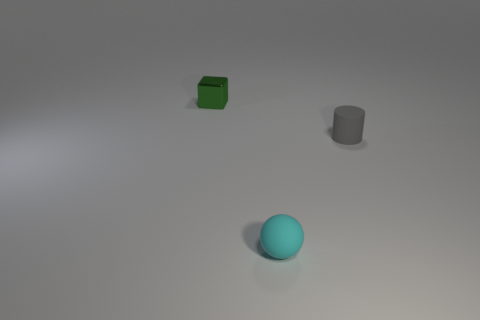Add 1 large blue rubber things. How many objects exist? 4 Subtract all cylinders. How many objects are left? 2 Subtract 1 cylinders. How many cylinders are left? 0 Subtract all brown balls. How many purple blocks are left? 0 Subtract all blocks. Subtract all small gray matte objects. How many objects are left? 1 Add 1 small cylinders. How many small cylinders are left? 2 Add 3 small blue shiny blocks. How many small blue shiny blocks exist? 3 Subtract 0 purple cubes. How many objects are left? 3 